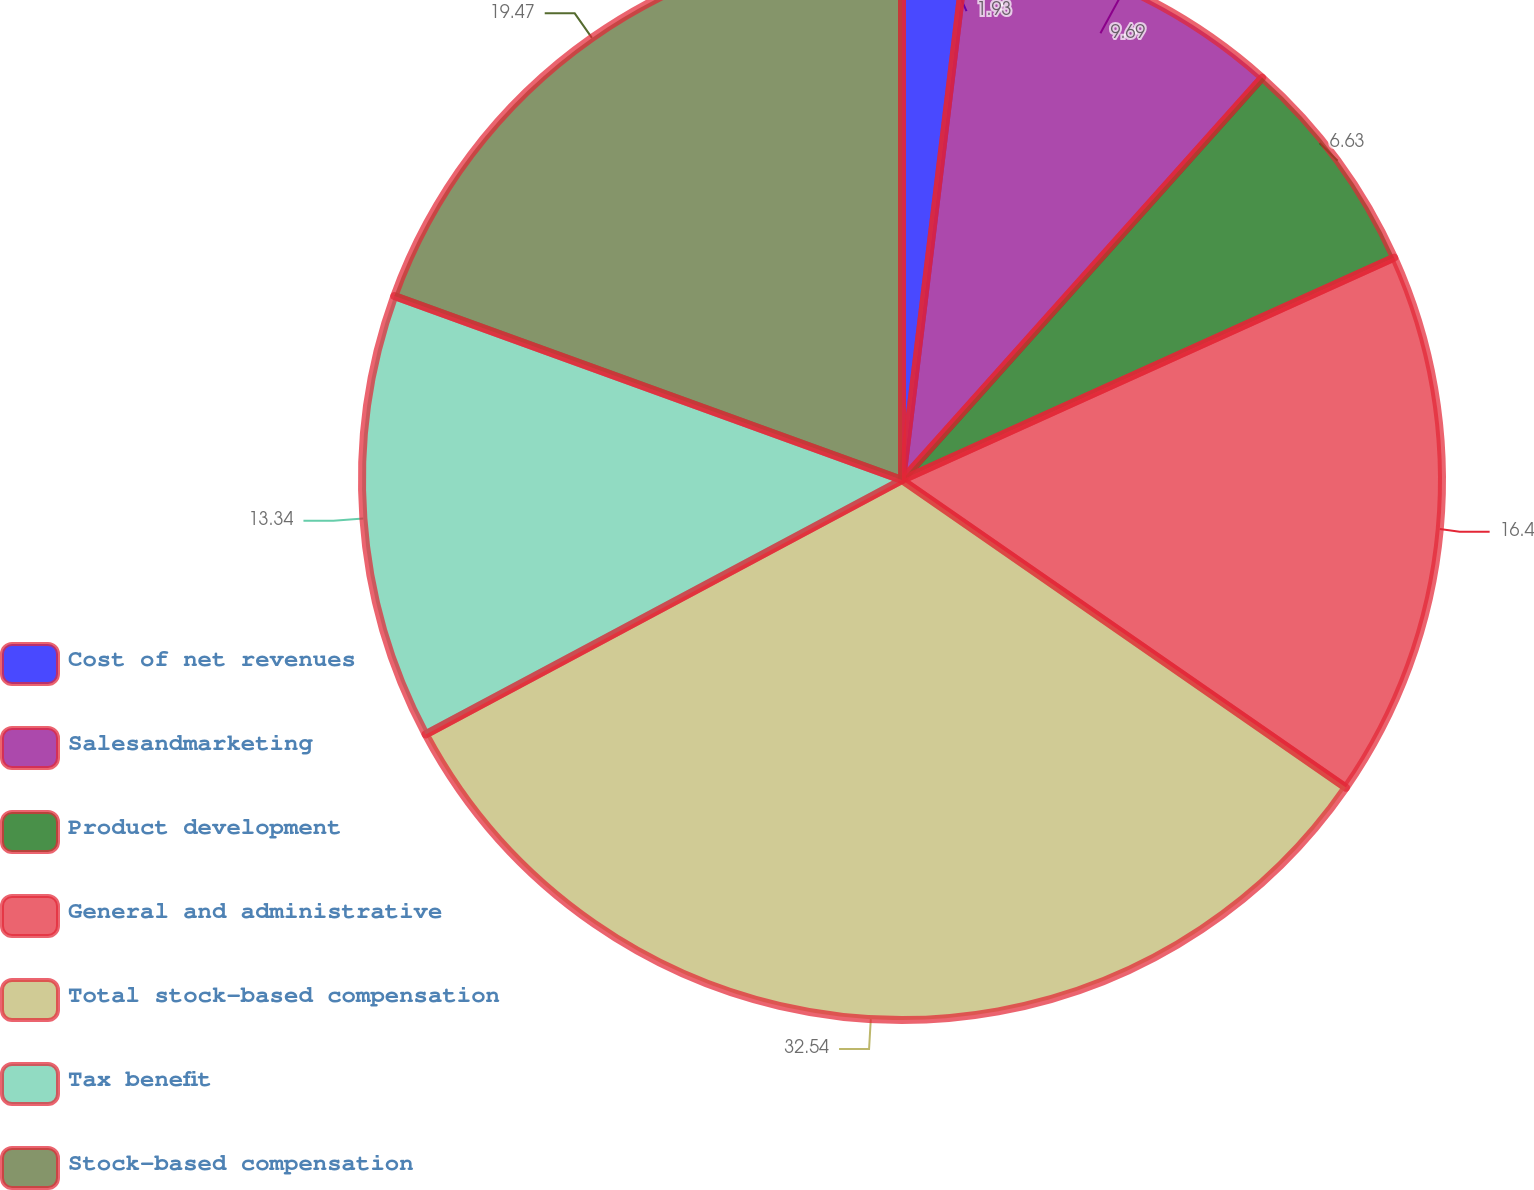Convert chart. <chart><loc_0><loc_0><loc_500><loc_500><pie_chart><fcel>Cost of net revenues<fcel>Salesandmarketing<fcel>Product development<fcel>General and administrative<fcel>Total stock-based compensation<fcel>Tax benefit<fcel>Stock-based compensation<nl><fcel>1.93%<fcel>9.69%<fcel>6.63%<fcel>16.4%<fcel>32.55%<fcel>13.34%<fcel>19.47%<nl></chart> 